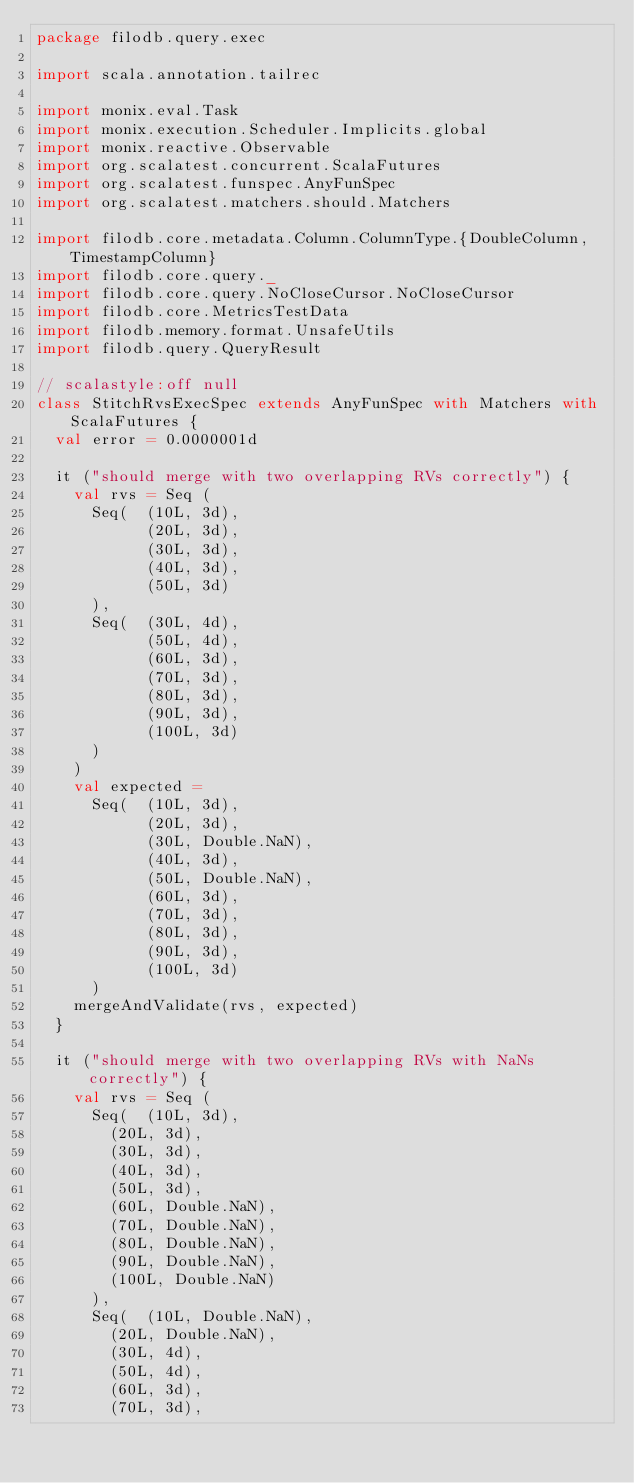Convert code to text. <code><loc_0><loc_0><loc_500><loc_500><_Scala_>package filodb.query.exec

import scala.annotation.tailrec

import monix.eval.Task
import monix.execution.Scheduler.Implicits.global
import monix.reactive.Observable
import org.scalatest.concurrent.ScalaFutures
import org.scalatest.funspec.AnyFunSpec
import org.scalatest.matchers.should.Matchers

import filodb.core.metadata.Column.ColumnType.{DoubleColumn, TimestampColumn}
import filodb.core.query._
import filodb.core.query.NoCloseCursor.NoCloseCursor
import filodb.core.MetricsTestData
import filodb.memory.format.UnsafeUtils
import filodb.query.QueryResult

// scalastyle:off null
class StitchRvsExecSpec extends AnyFunSpec with Matchers with ScalaFutures {
  val error = 0.0000001d

  it ("should merge with two overlapping RVs correctly") {
    val rvs = Seq (
      Seq(  (10L, 3d),
            (20L, 3d),
            (30L, 3d),
            (40L, 3d),
            (50L, 3d)
      ),
      Seq(  (30L, 4d),
            (50L, 4d),
            (60L, 3d),
            (70L, 3d),
            (80L, 3d),
            (90L, 3d),
            (100L, 3d)
      )
    )
    val expected =
      Seq(  (10L, 3d),
            (20L, 3d),
            (30L, Double.NaN),
            (40L, 3d),
            (50L, Double.NaN),
            (60L, 3d),
            (70L, 3d),
            (80L, 3d),
            (90L, 3d),
            (100L, 3d)
      )
    mergeAndValidate(rvs, expected)
  }

  it ("should merge with two overlapping RVs with NaNs correctly") {
    val rvs = Seq (
      Seq(  (10L, 3d),
        (20L, 3d),
        (30L, 3d),
        (40L, 3d),
        (50L, 3d),
        (60L, Double.NaN),
        (70L, Double.NaN),
        (80L, Double.NaN),
        (90L, Double.NaN),
        (100L, Double.NaN)
      ),
      Seq(  (10L, Double.NaN),
        (20L, Double.NaN),
        (30L, 4d),
        (50L, 4d),
        (60L, 3d),
        (70L, 3d),</code> 